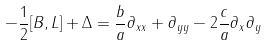<formula> <loc_0><loc_0><loc_500><loc_500>- \frac { 1 } { 2 } [ B , L ] + \Delta = \frac { b } { a } \partial _ { x x } + \partial _ { y y } - 2 \frac { c } { a } \partial _ { x } \partial _ { y }</formula> 